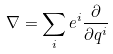Convert formula to latex. <formula><loc_0><loc_0><loc_500><loc_500>\nabla = \sum _ { i } e ^ { i } \frac { \partial } { \partial q ^ { i } }</formula> 